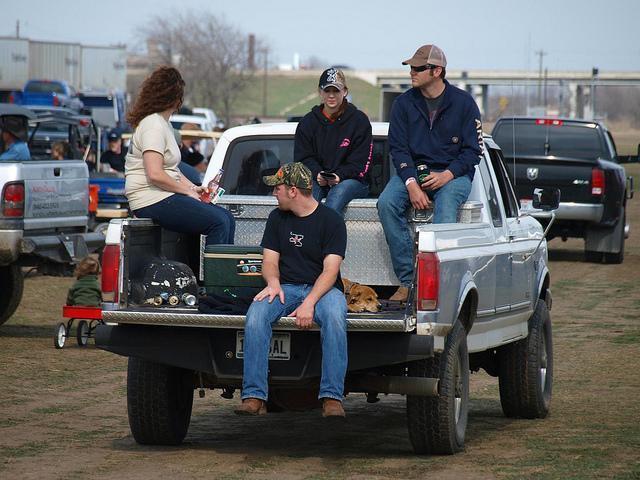What is the name for this sort of event?
Make your selection and explain in format: 'Answer: answer
Rationale: rationale.'
Options: Fight, tailgate, stakeout, drive. Answer: tailgate.
Rationale: People do this thing called tailgating to have fun before a big event. 